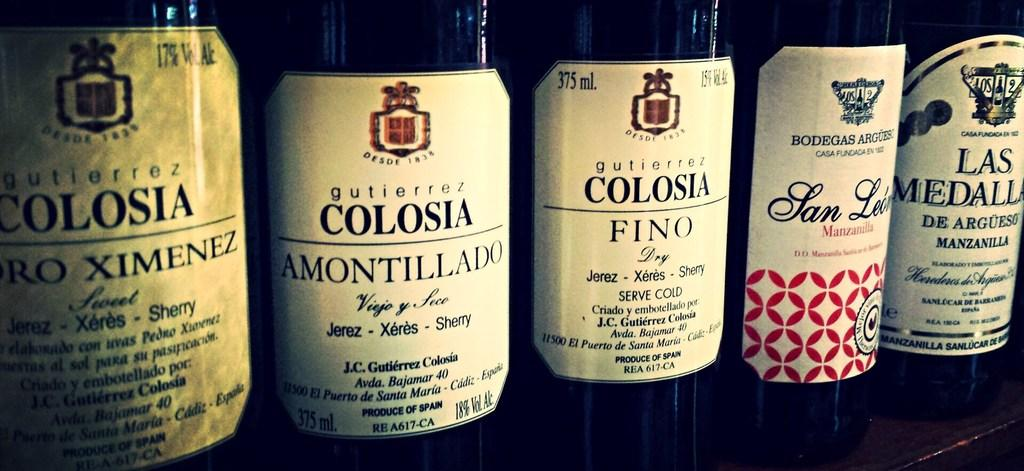<image>
Write a terse but informative summary of the picture. Five bottles of wine are lined up on a shelf, but only three of them are made by Gutierrez Colosia. 